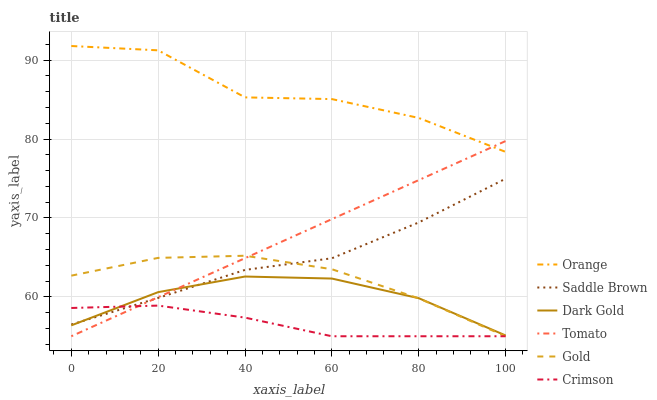Does Gold have the minimum area under the curve?
Answer yes or no. No. Does Gold have the maximum area under the curve?
Answer yes or no. No. Is Gold the smoothest?
Answer yes or no. No. Is Gold the roughest?
Answer yes or no. No. Does Dark Gold have the lowest value?
Answer yes or no. No. Does Gold have the highest value?
Answer yes or no. No. Is Saddle Brown less than Orange?
Answer yes or no. Yes. Is Orange greater than Dark Gold?
Answer yes or no. Yes. Does Saddle Brown intersect Orange?
Answer yes or no. No. 